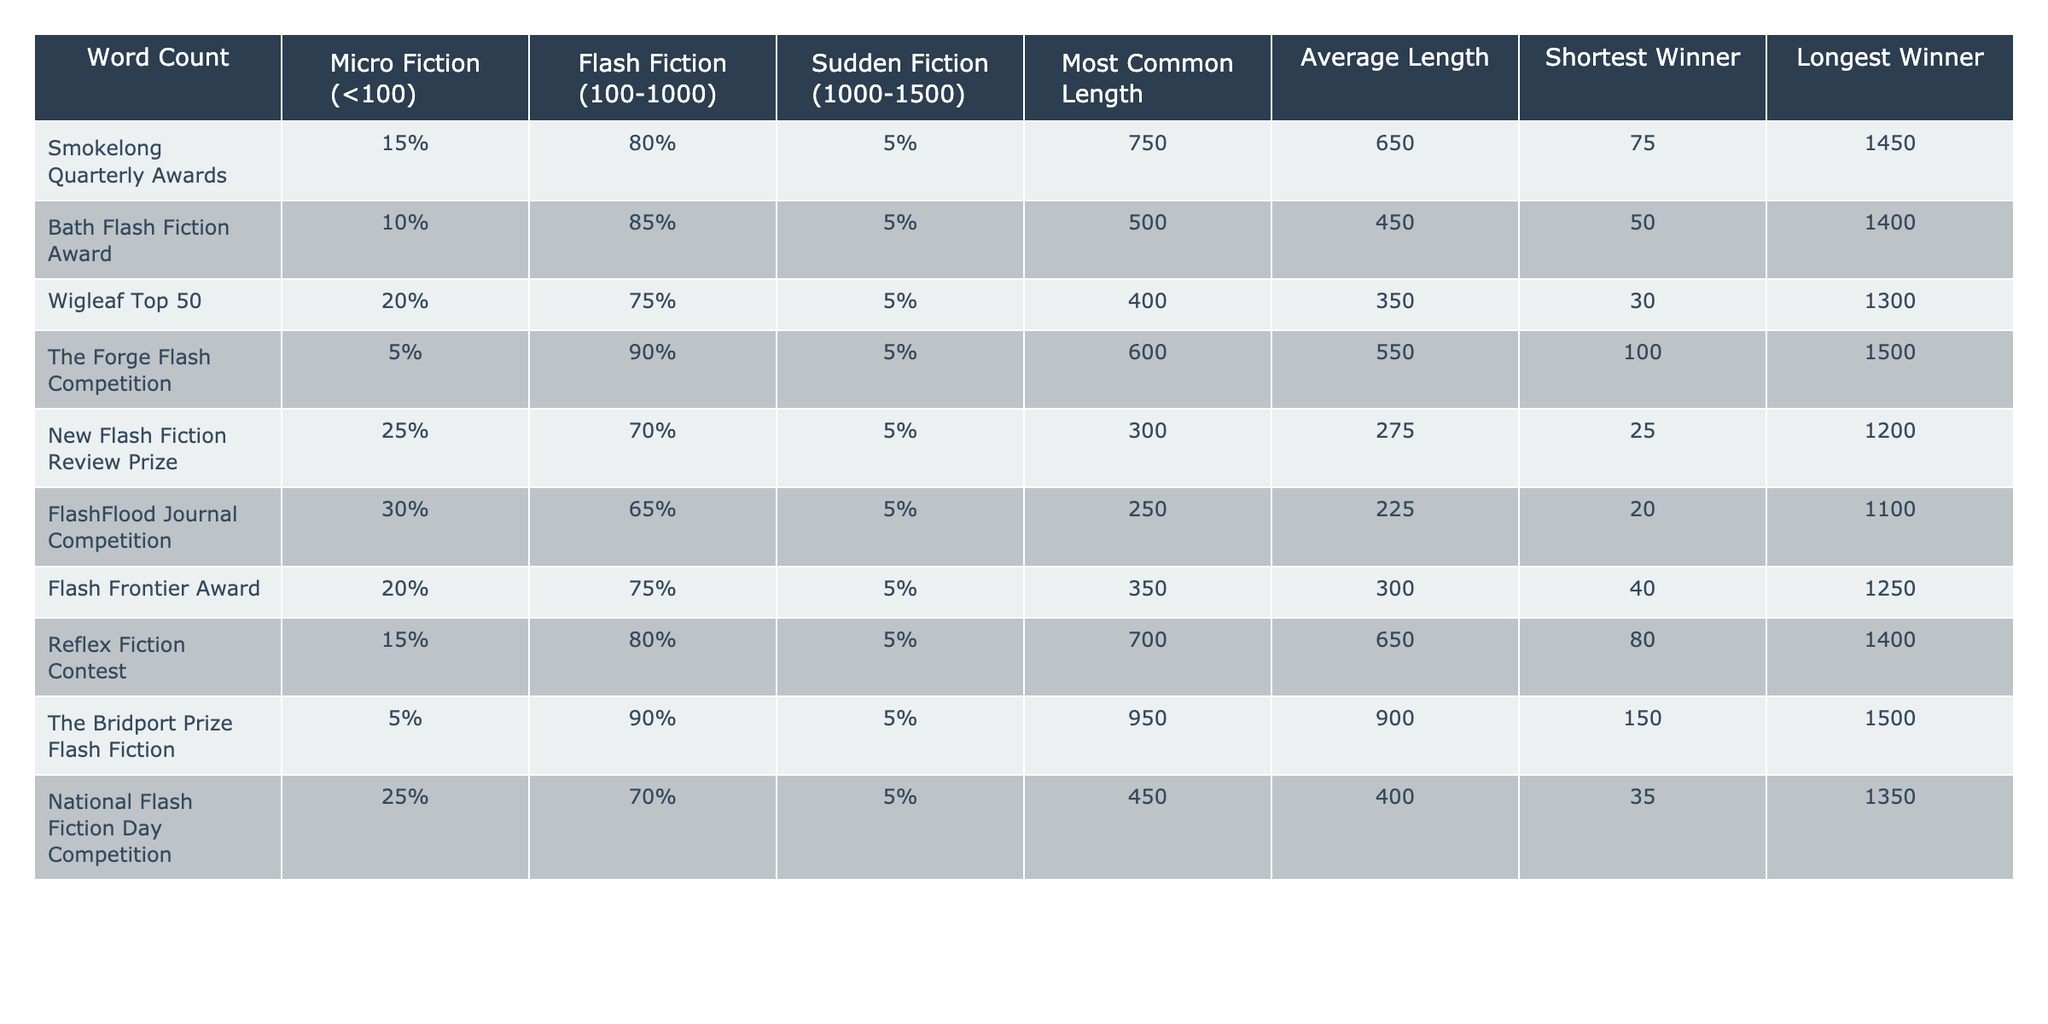What percentage of winning entries in the FlashFlood Journal Competition are classified as Micro Fiction? From the table, we can see that the Micro Fiction percentage for FlashFlood Journal Competition is listed as 30%.
Answer: 30% What is the most common length of award-winning flash fiction stories in the Wigleaf Top 50? According to the table, the most common length for Wigleaf Top 50 is 400 words.
Answer: 400 What is the average length of entries in the National Flash Fiction Day Competition? The average length for entries in the National Flash Fiction Day Competition is provided in the table as 400 words.
Answer: 400 Which award has the longest winning entry and what is its length? The table indicates that The Bridport Prize Flash Fiction has the longest winning entry at 1500 words.
Answer: 1500 What is the combined percentage of Micro Fiction and Flash Fiction for the Bath Flash Fiction Award? The table shows 10% for Micro Fiction and 85% for Flash Fiction for this award. Adding these gives a total of 95%.
Answer: 95% Is there a competition where Micro Fiction entries are greater than 25%? Looking at the table, the FlashFlood Journal Competition and the New Flash Fiction Review Prize both have Micro Fiction entries at or above 25%. Therefore, the answer is yes.
Answer: Yes What is the difference between the shortest and longest winning entry in the Smokelong Quarterly Awards? The table states the shortest winner is 75 words and the longest winner is 1450 words. The difference is 1450 - 75 = 1375.
Answer: 1375 What is the average length of the winners for all awards combined? To find this, we can sum the average lengths from each award and then divide by the number of awards. The averages are 650, 450, 350, 550, 275, 225, 300, 650, 900, 400, which totals to 4875, and dividing by 10 yields an average of 487.5.
Answer: 487.5 Which award has the lowest percentage of Flash Fiction entries? The lowest percentage of Flash Fiction entries is found in the FlashFlood Journal Competition at 65%.
Answer: 65% Are there any awards where the most common length is below 500 words? Yes, both the New Flash Fiction Review Prize and the FlashFlood Journal Competition have a most common length below 500 words, at 300 and 250 words respectively.
Answer: Yes 